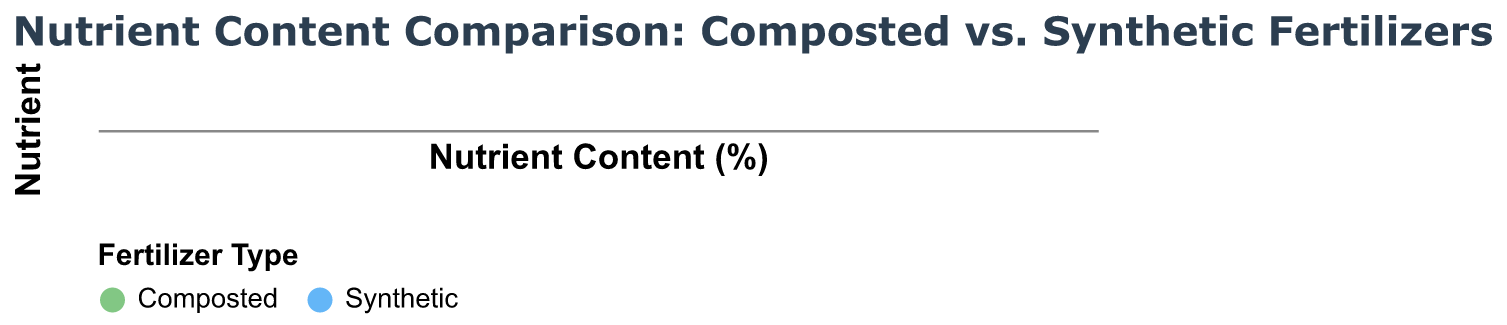What are the two types of fertilizers compared in the figure? The two types of fertilizers compared are indicated by the colors and the legend at the bottom of the figure. They are "Composted" and "Synthetic".
Answer: Composted and Synthetic Which vegetable has the highest nitrogen content when using synthetic fertilizer? To find this, look at the row labeled "Nitrogen (%)" and compare the nitrogen contents for each vegetable with synthetic fertilizer (blue points). Spinach has the highest value.
Answer: Spinach What is the phosphorus content for lettuce with composted fertilizer? Locate the vegetable "Lettuce" in the figure and in the row labeled "Phosphorus (%)". The point representing "Composted" (green) for lettuce shows a value of 0.6.
Answer: 0.6 How much higher is the potassium content in synthetic fertilizer for bell peppers compared to composted fertilizer? Identify the potassium content for bell peppers from both types of fertilizers. Potassium content for synthetic is 1.9 and for composted is 1.1. The difference is 1.9 - 1.1 = 0.8.
Answer: 0.8 Which nutrient shows the smallest difference between composted and synthetic fertilizers across all vegetables? Compare the differences for nitrogen, phosphorus, and potassium between the two fertilizer types for each vegetable and find the smallest. Phosphorus generally has smaller differences compared to nitrogen and potassium.
Answer: Phosphorus Is Nitrogen content always higher in synthetic fertilizer compared to composted fertilizer for each vegetable? Check the nitrogen content for each vegetable in the nitrogen row. Synthetic fertilizer (blue) is consistently higher in nitrogen content compared to composted fertilizer (green) in all cases.
Answer: Yes What is the average potassium content for tomatoes using both fertilizer types? To find the average, first note the potassium contents for tomatoes: 1.2 for composted and 2.0 for synthetic. Calculate the average (1.2 + 2.0)/2 = 1.6.
Answer: 1.6 In which nutrient category does spinach have the greatest advantage of synthetic fertilizer over composted fertilizer? Compare the difference for spinach across nitrogen, phosphorus, and potassium. The largest difference is seen in potassium, where synthetic is 2.1 and composted is 1.1, a difference of 1.0.
Answer: Potassium Between nitrogen, phosphorus, and potassium, which nutrient shows the most substantial difference in favor of synthetic fertilizer overall? By examining the nutrient rows for all vegetables, nitrogen tends to show the largest differences in favor of synthetic fertilizer across most vegetables, consistently showing higher synthetic values.
Answer: Nitrogen 